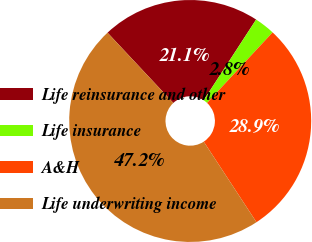Convert chart to OTSL. <chart><loc_0><loc_0><loc_500><loc_500><pie_chart><fcel>Life reinsurance and other<fcel>Life insurance<fcel>A&H<fcel>Life underwriting income<nl><fcel>21.15%<fcel>2.75%<fcel>28.85%<fcel>47.25%<nl></chart> 